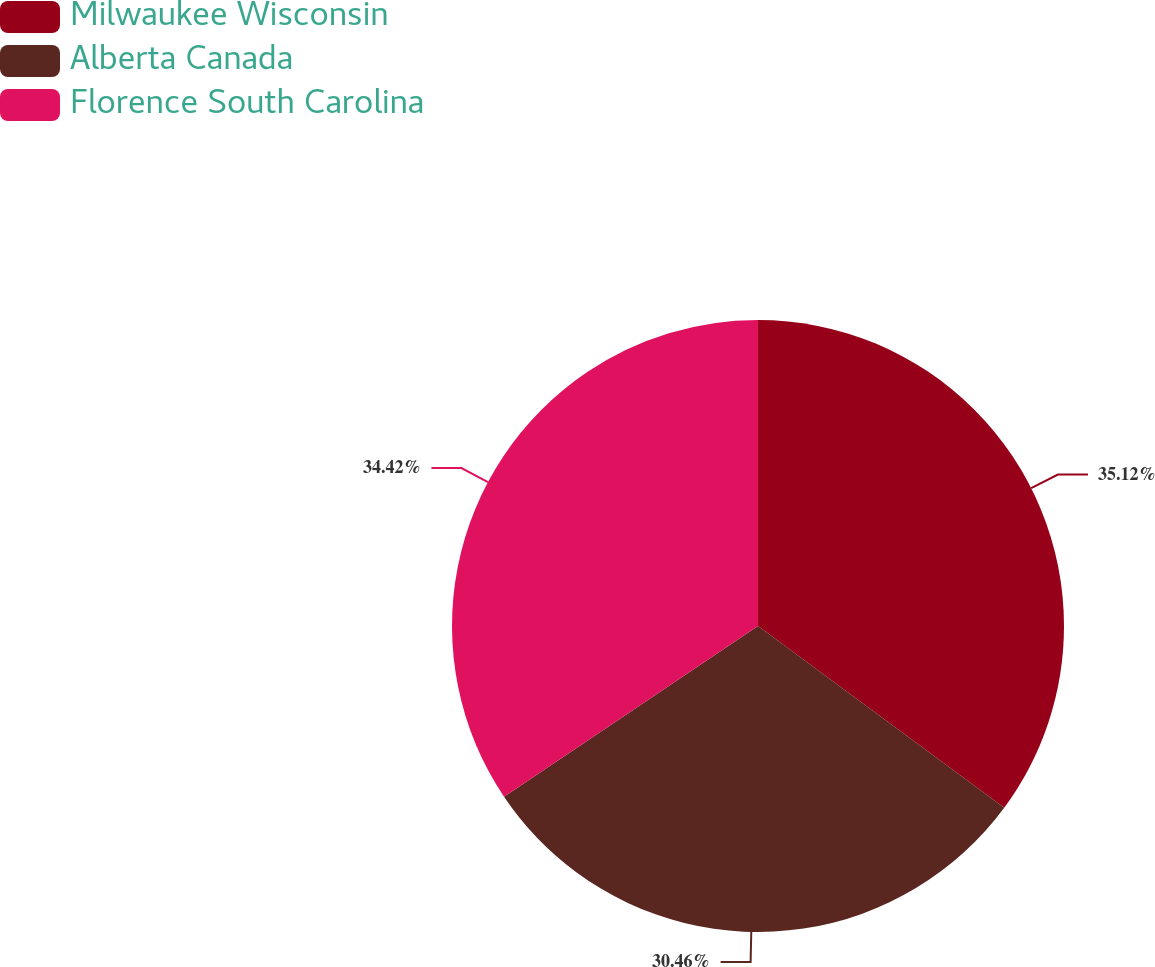Convert chart. <chart><loc_0><loc_0><loc_500><loc_500><pie_chart><fcel>Milwaukee Wisconsin<fcel>Alberta Canada<fcel>Florence South Carolina<nl><fcel>35.12%<fcel>30.46%<fcel>34.42%<nl></chart> 